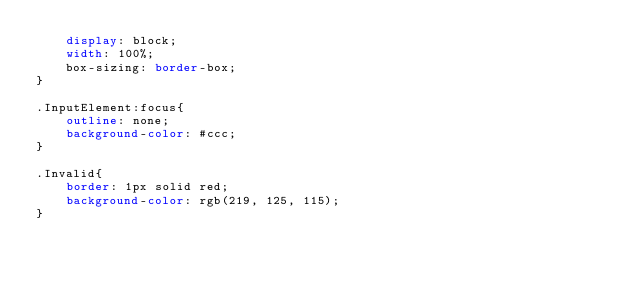<code> <loc_0><loc_0><loc_500><loc_500><_CSS_>    display: block;
    width: 100%;
    box-sizing: border-box;
}

.InputElement:focus{
    outline: none;
    background-color: #ccc;
}

.Invalid{
    border: 1px solid red;
    background-color: rgb(219, 125, 115);
}</code> 